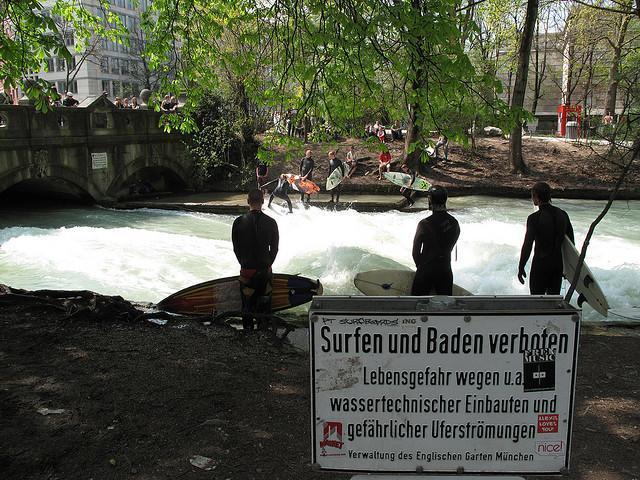How many people can you see?
Give a very brief answer. 3. 